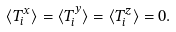Convert formula to latex. <formula><loc_0><loc_0><loc_500><loc_500>\langle T _ { i } ^ { x } \rangle = \langle T _ { i } ^ { y } \rangle = \langle T _ { i } ^ { z } \rangle = 0 .</formula> 